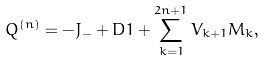<formula> <loc_0><loc_0><loc_500><loc_500>Q ^ { ( n ) } = - J _ { - } + D 1 + \sum _ { k = 1 } ^ { 2 n + 1 } V _ { k + 1 } M _ { k } ,</formula> 